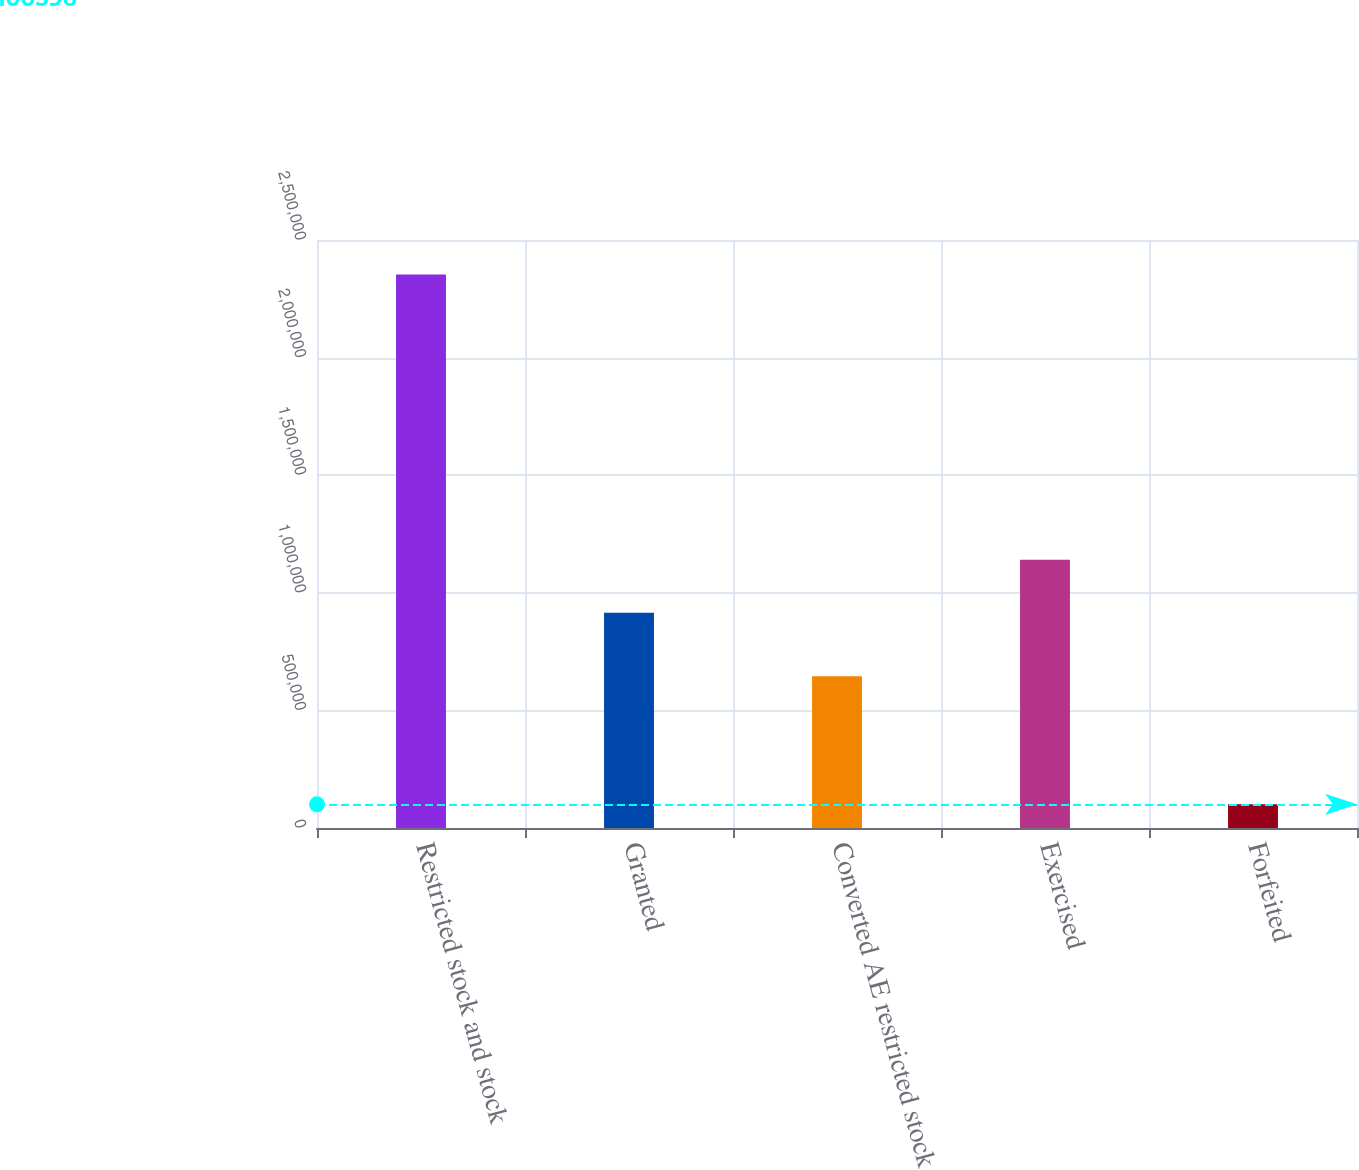Convert chart to OTSL. <chart><loc_0><loc_0><loc_500><loc_500><bar_chart><fcel>Restricted stock and stock<fcel>Granted<fcel>Converted AE restricted stock<fcel>Exercised<fcel>Forfeited<nl><fcel>2.35313e+06<fcel>915054<fcel>645197<fcel>1.14031e+06<fcel>100596<nl></chart> 